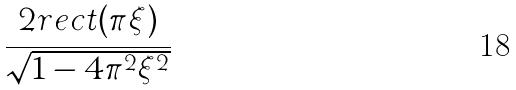Convert formula to latex. <formula><loc_0><loc_0><loc_500><loc_500>\frac { 2 r e c t ( \pi \xi ) } { \sqrt { 1 - 4 \pi ^ { 2 } \xi ^ { 2 } } }</formula> 